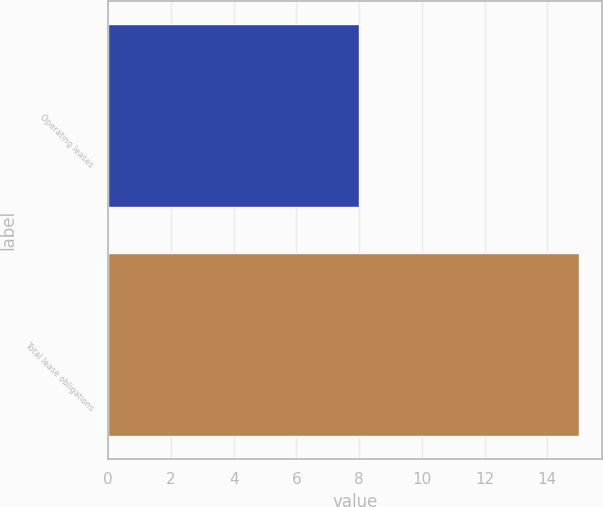Convert chart to OTSL. <chart><loc_0><loc_0><loc_500><loc_500><bar_chart><fcel>Operating leases<fcel>Total lease obligations<nl><fcel>8<fcel>15<nl></chart> 